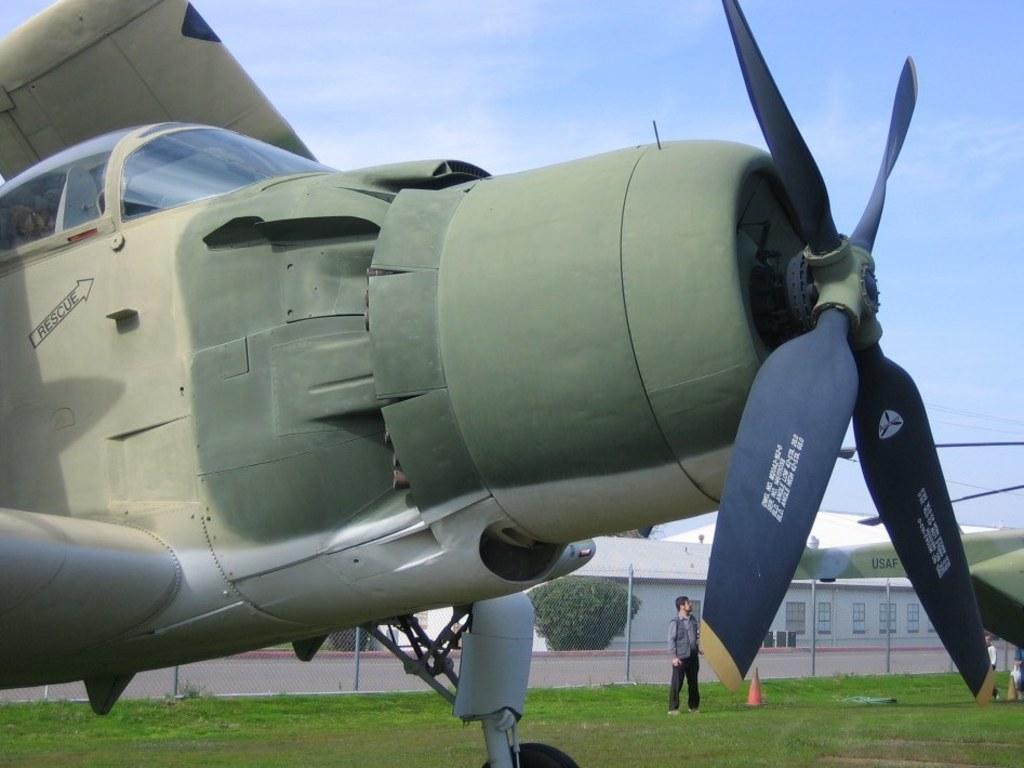How would you summarize this image in a sentence or two? In this picture, we see an aircraft in green color. It has spinners in blue color. Beside that, we see a man in grey shirt is standing. Beside him, we see a traffic stopper. Behind him, we see poles. At the bottom of the picture, we see the grass. On the right side, we see another aircraft. In the background, we see trees and a building in white color. At the top of the picture, we see the sky. 